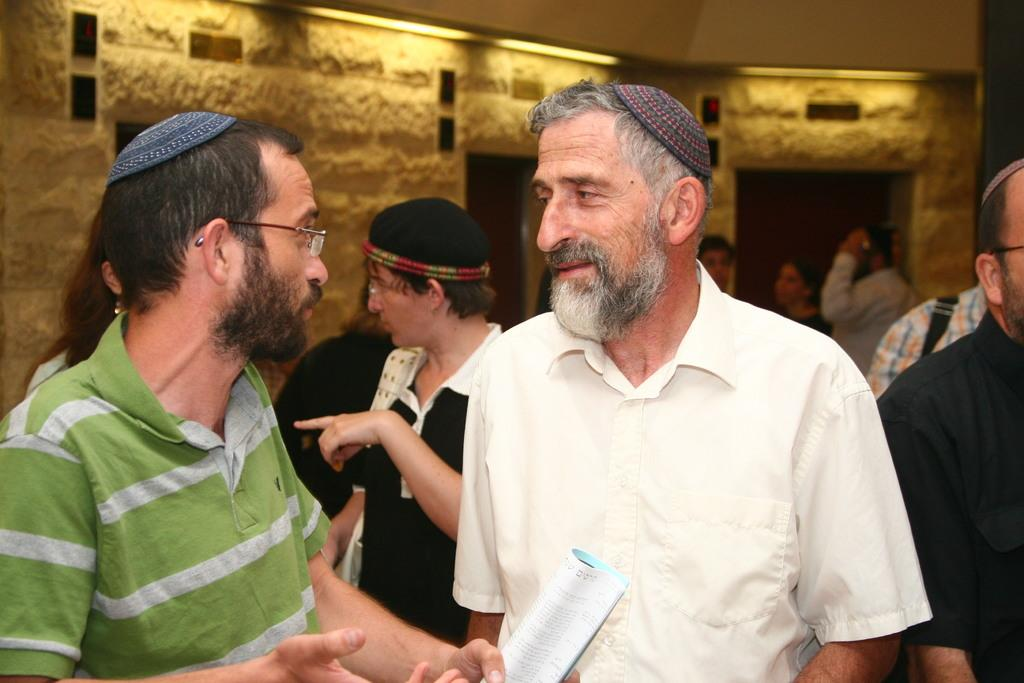Who or what can be seen in the image? There are people in the image. What is present in the background of the image? There is a wall in the image. What can be seen illuminating the scene? There are lights in the image. What is the man in the front of the image holding? The man is holding a book in the front of the image. What color is the paint on the man's toes in the image? There is no mention of paint or toes in the image, so we cannot determine the color of any paint on the man's toes. 